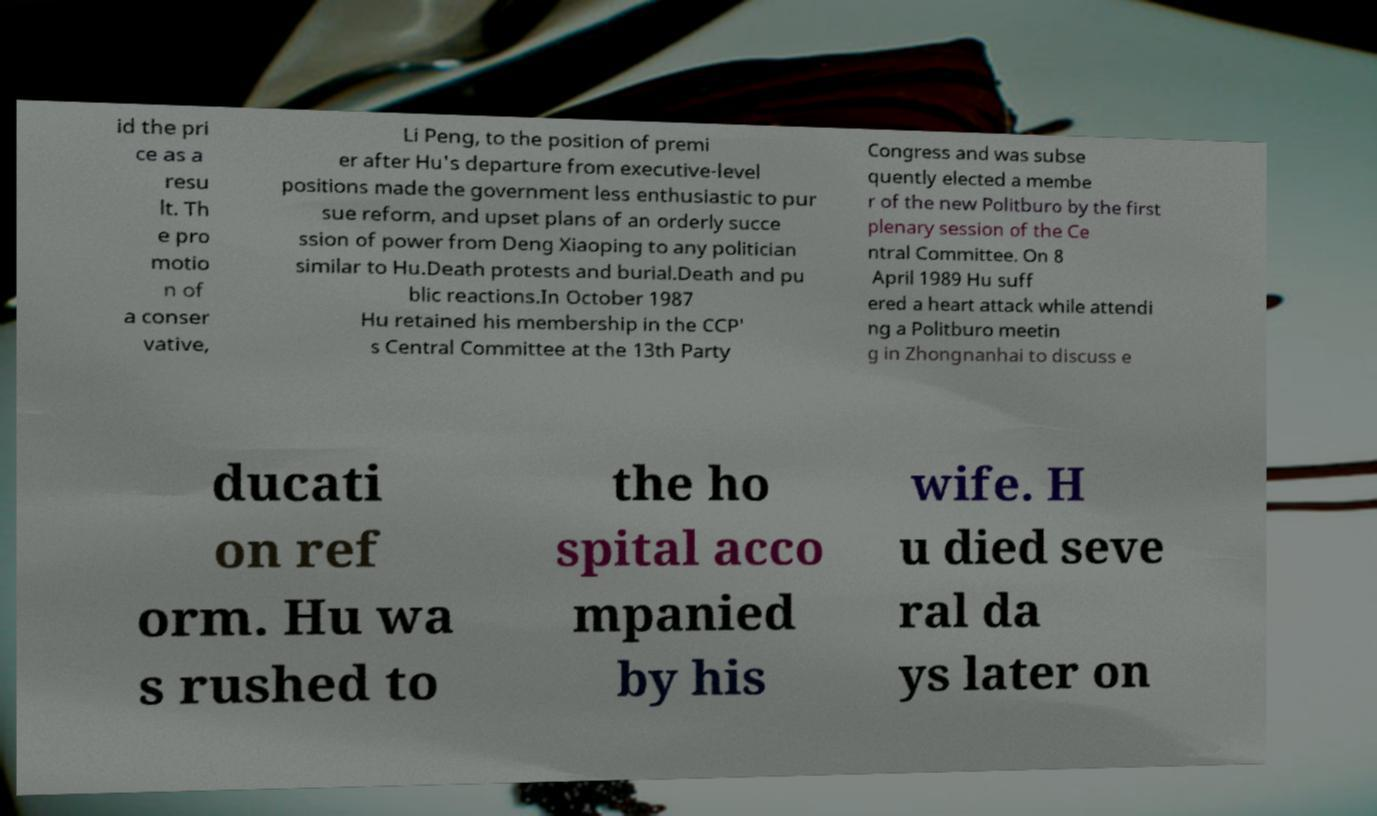Please read and relay the text visible in this image. What does it say? id the pri ce as a resu lt. Th e pro motio n of a conser vative, Li Peng, to the position of premi er after Hu's departure from executive-level positions made the government less enthusiastic to pur sue reform, and upset plans of an orderly succe ssion of power from Deng Xiaoping to any politician similar to Hu.Death protests and burial.Death and pu blic reactions.In October 1987 Hu retained his membership in the CCP' s Central Committee at the 13th Party Congress and was subse quently elected a membe r of the new Politburo by the first plenary session of the Ce ntral Committee. On 8 April 1989 Hu suff ered a heart attack while attendi ng a Politburo meetin g in Zhongnanhai to discuss e ducati on ref orm. Hu wa s rushed to the ho spital acco mpanied by his wife. H u died seve ral da ys later on 